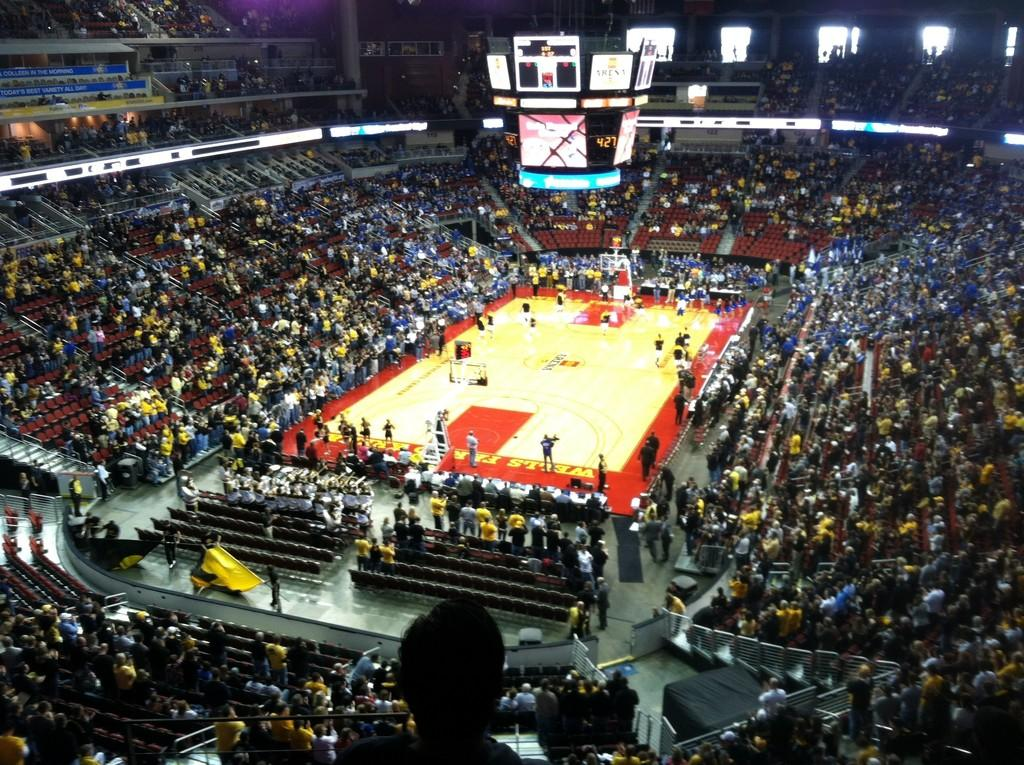<image>
Describe the image concisely. A crowded stadium watches a basketball game in the Wells Fargo Arena. 